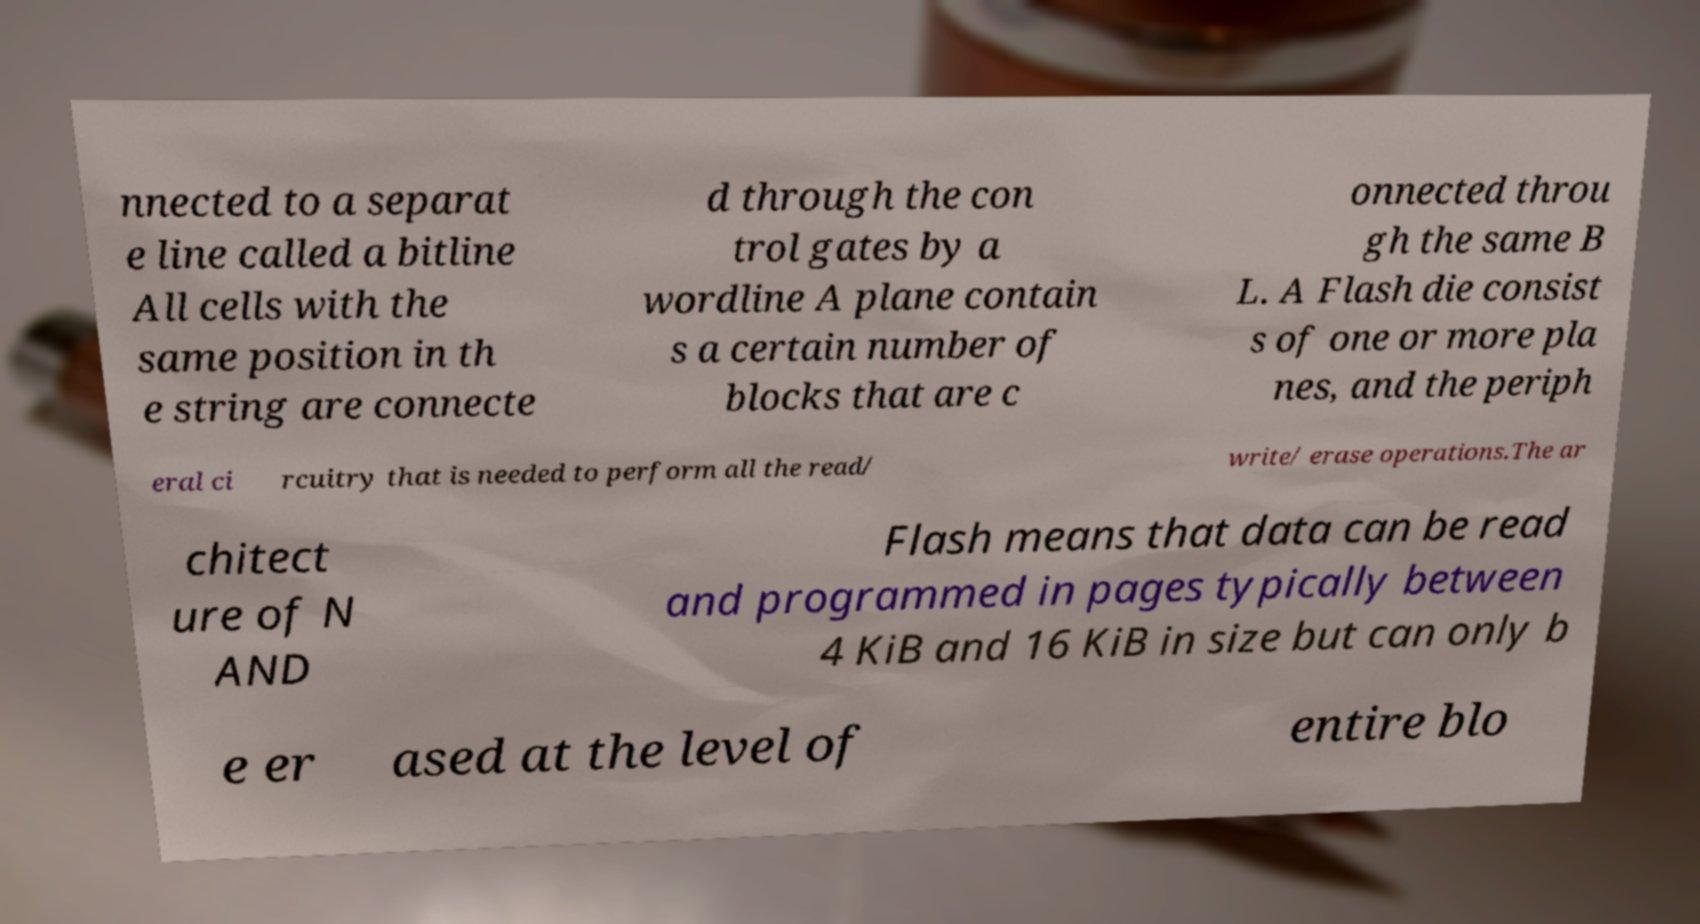Can you read and provide the text displayed in the image?This photo seems to have some interesting text. Can you extract and type it out for me? nnected to a separat e line called a bitline All cells with the same position in th e string are connecte d through the con trol gates by a wordline A plane contain s a certain number of blocks that are c onnected throu gh the same B L. A Flash die consist s of one or more pla nes, and the periph eral ci rcuitry that is needed to perform all the read/ write/ erase operations.The ar chitect ure of N AND Flash means that data can be read and programmed in pages typically between 4 KiB and 16 KiB in size but can only b e er ased at the level of entire blo 